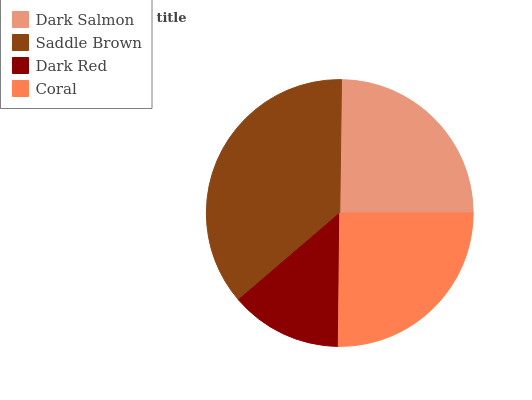Is Dark Red the minimum?
Answer yes or no. Yes. Is Saddle Brown the maximum?
Answer yes or no. Yes. Is Saddle Brown the minimum?
Answer yes or no. No. Is Dark Red the maximum?
Answer yes or no. No. Is Saddle Brown greater than Dark Red?
Answer yes or no. Yes. Is Dark Red less than Saddle Brown?
Answer yes or no. Yes. Is Dark Red greater than Saddle Brown?
Answer yes or no. No. Is Saddle Brown less than Dark Red?
Answer yes or no. No. Is Coral the high median?
Answer yes or no. Yes. Is Dark Salmon the low median?
Answer yes or no. Yes. Is Saddle Brown the high median?
Answer yes or no. No. Is Saddle Brown the low median?
Answer yes or no. No. 